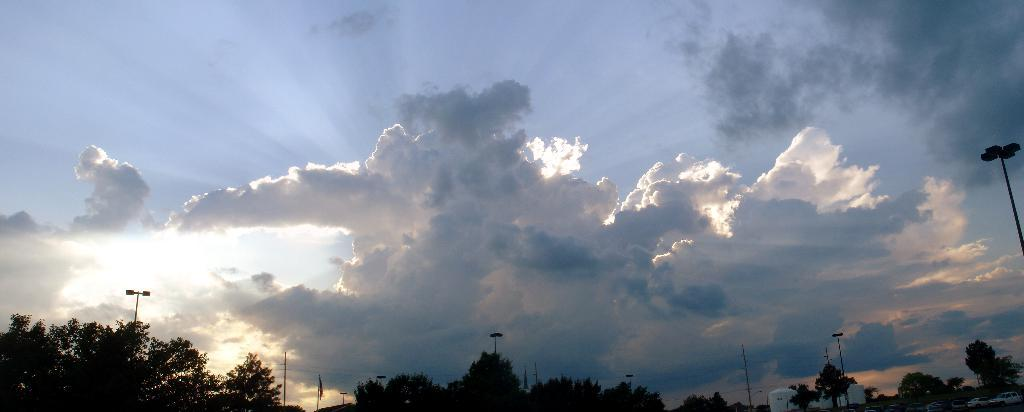What is the weather like in the image? The sky in the image is cloudy. What type of vegetation can be seen at the bottom of the image? There are many trees at the bottom of the image. What structures are visible in the image? Poles and containers are present in the image. What is attached to the poles in the image? A flag is present in the image. What else can be seen in the image besides the trees and poles? Vehicles are visible in the image. Are there any wires visible in the image? Yes, wires are visible in the image. Can you tell me how many stores are present in the image? There are no stores visible in the image. What type of tree is the maid standing next to in the image? There is no tree or maid present in the image. 